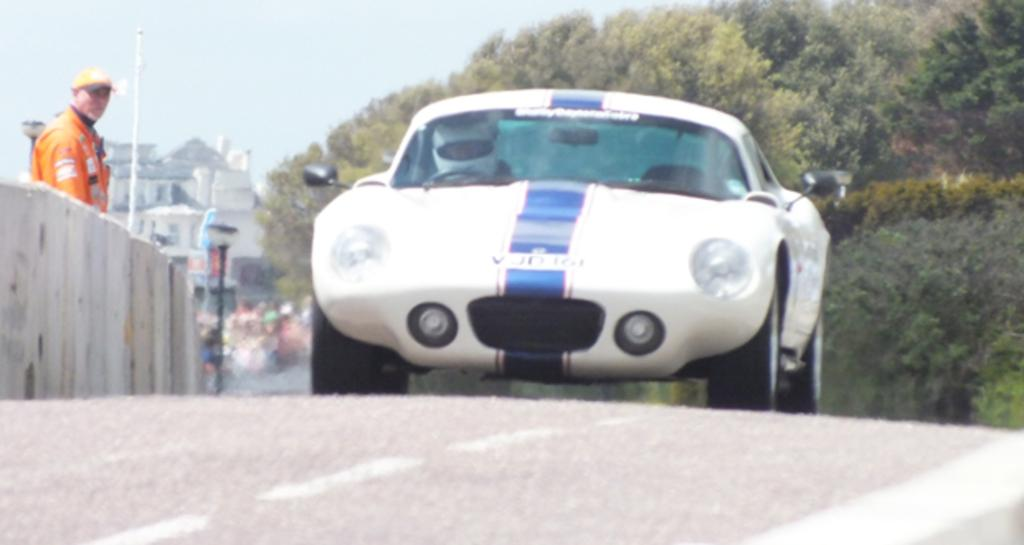What is the main subject of the image? The main subject of the image is a car on the road. Can you describe the man in the image? There is a man standing at the fence in the image. What type of natural elements can be seen in the image? There are trees in the image. What type of structures are visible in the image? There are buildings in the image. What is visible in the background of the image? The sky is visible in the background of the image. What type of horn is the man playing in the image? There is no horn present in the image; the man is standing at the fence. What type of plants can be seen growing in the image? There is no specific mention of plants in the image, only trees. 